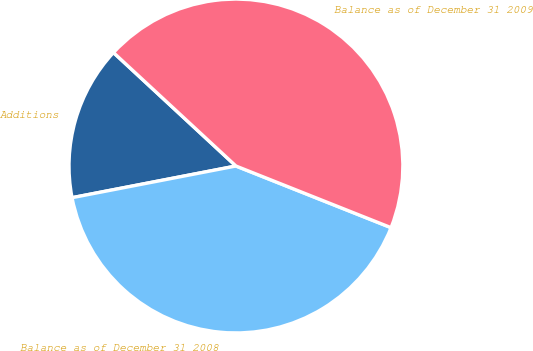<chart> <loc_0><loc_0><loc_500><loc_500><pie_chart><fcel>Additions<fcel>Balance as of December 31 2008<fcel>Balance as of December 31 2009<nl><fcel>14.93%<fcel>40.94%<fcel>44.13%<nl></chart> 